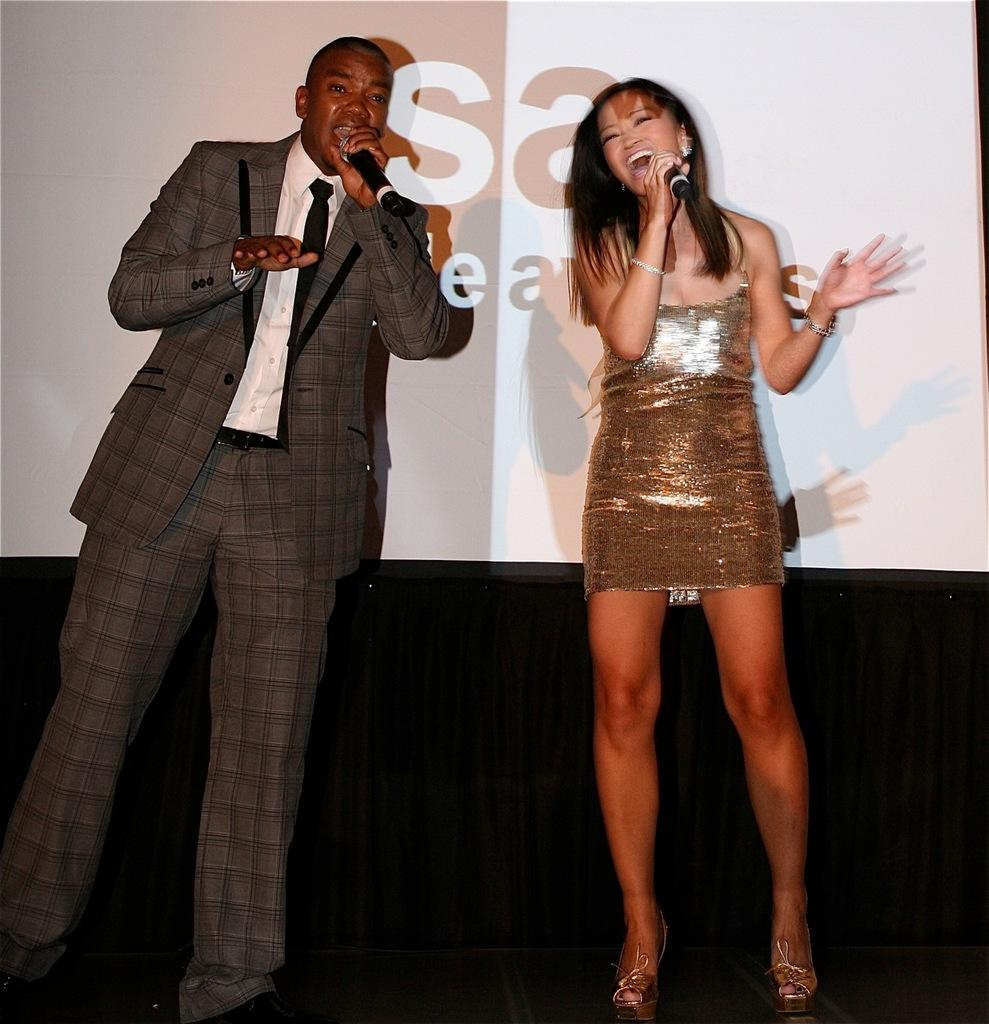Who are the people in the image? There is a man and a woman in the image. What are the man and woman doing in the image? The man and woman are standing on a platform and holding microphones in their hands. What can be seen in the background of the image? There is a banner in the background of the image. What type of engine is visible in the image? There is no engine present in the image. How long does the minute hand move in the image? There is no clock or time-related element in the image, so it is not possible to determine the movement of a minute hand. 